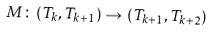<formula> <loc_0><loc_0><loc_500><loc_500>M \colon \, ( T _ { k } , T _ { k + 1 } ) \rightarrow \, ( T _ { k + 1 } , T _ { k + 2 } )</formula> 